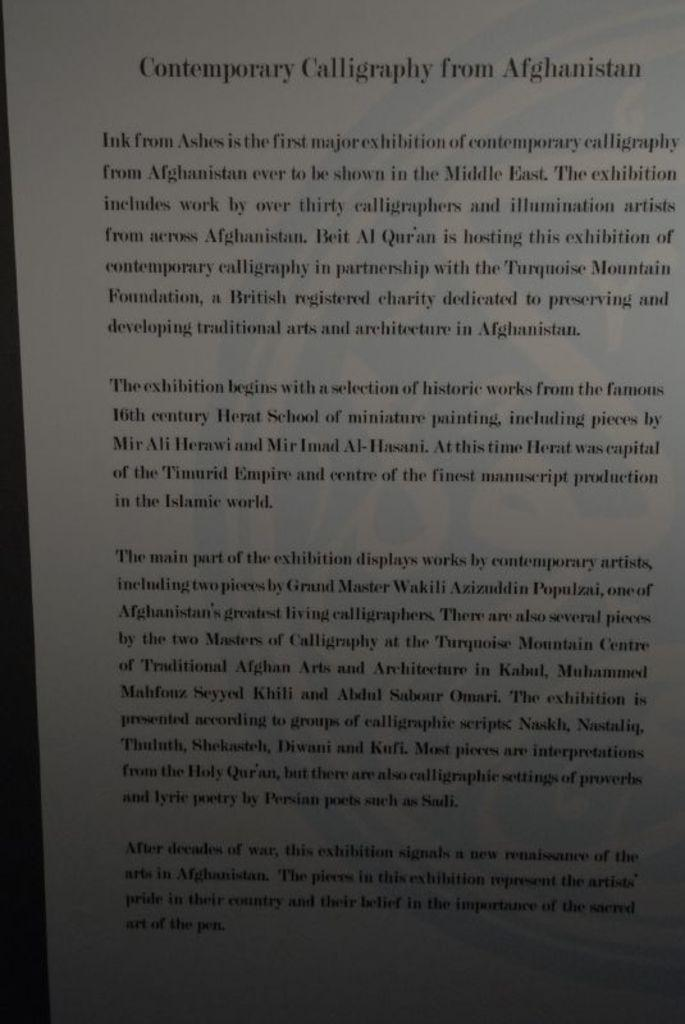<image>
Give a short and clear explanation of the subsequent image. A page of a book labeled Contemporary Calligraphy of Afghanistan. 